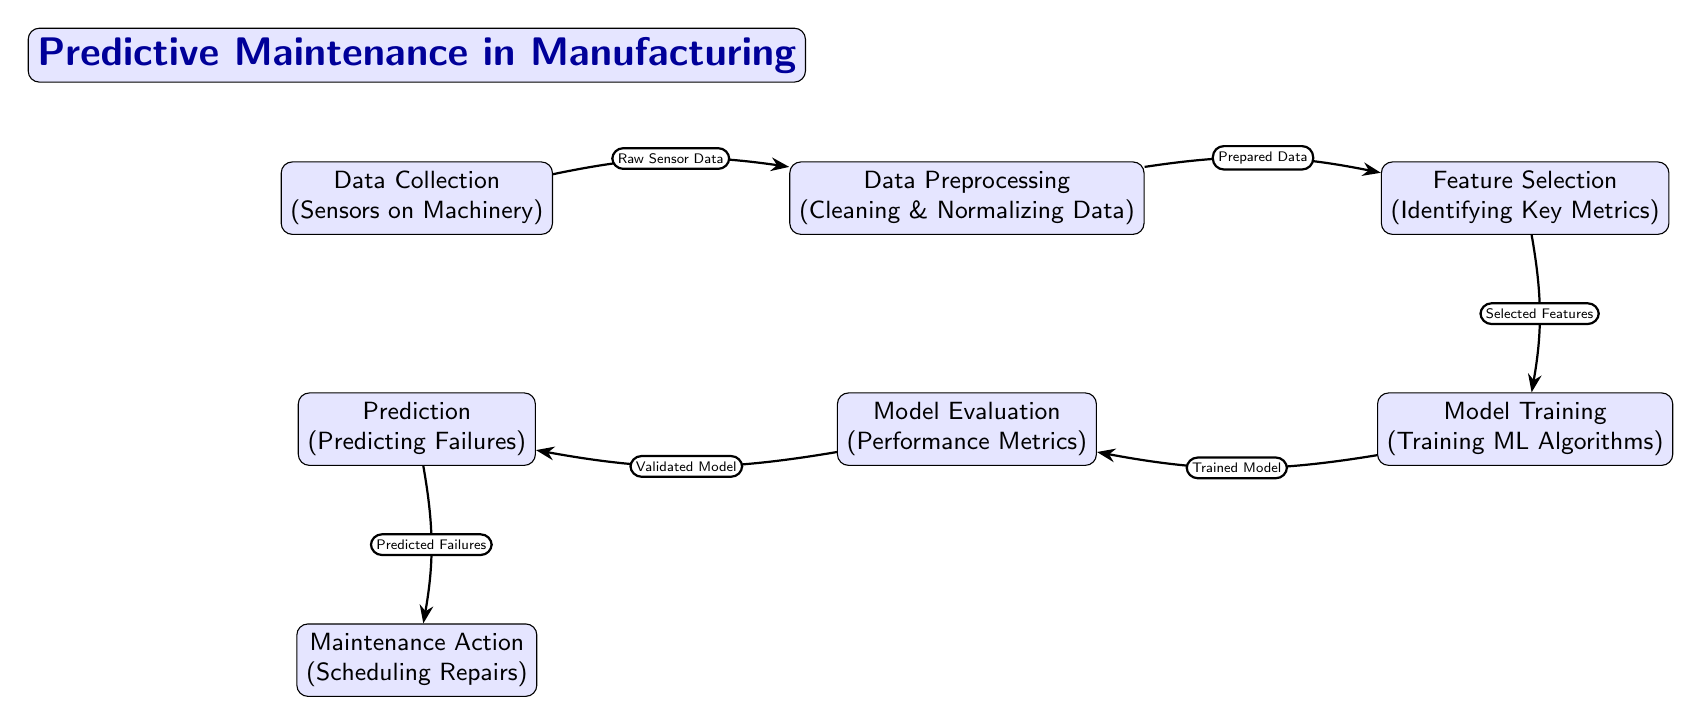What does the first node represent? The first node in the diagram is labeled "Data Collection" and describes the process of collecting data from sensors on machinery.
Answer: Data Collection (Sensors on Machinery) How many nodes are in the diagram? By counting each distinct labeled node, we find there are seven nodes in the diagram total.
Answer: Seven What is the role of the "Feature Selection" node? The "Feature Selection" node is responsible for identifying key metrics that are important for the predictive maintenance process.
Answer: Identifying Key Metrics Which node follows "Model Training"? The "Model Evaluation" node follows "Model Training" in the order of the predictive maintenance process.
Answer: Model Evaluation What data does the "Data Preprocessing" node receive? The "Data Preprocessing" node receives raw sensor data from the "Data Collection" node.
Answer: Raw Sensor Data What is the output of the "Prediction" node? The output of the "Prediction" node is the predicted failures which leads to maintenance actions.
Answer: Predicted Failures Describe the flow from "Data Collection" to "Maintenance Action". Starting from "Data Collection," raw sensor data is cleaned and normalized in "Data Preprocessing," which then moves to "Feature Selection" to identify key metrics. The selected features are trained in "Model Training," evaluated in "Model Evaluation," and then used to make predictions of failures in the "Prediction" node. Finally, this culminates in scheduling repairs in "Maintenance Action."
Answer: Data Collection → Data Preprocessing → Feature Selection → Model Training → Model Evaluation → Prediction → Maintenance Action What type of algorithm is involved in the "Model Training" node? The "Model Training" node involves training machine learning algorithms to create a predictive model.
Answer: Training ML Algorithms What happens after the "Model Evaluation"? After the "Model Evaluation," the validated model is then used for making predictions about potential equipment failures.
Answer: Prediction 